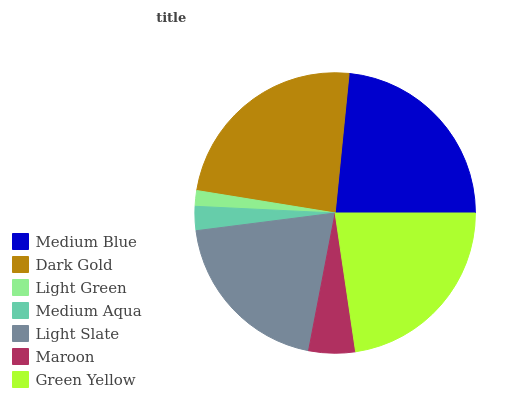Is Light Green the minimum?
Answer yes or no. Yes. Is Dark Gold the maximum?
Answer yes or no. Yes. Is Dark Gold the minimum?
Answer yes or no. No. Is Light Green the maximum?
Answer yes or no. No. Is Dark Gold greater than Light Green?
Answer yes or no. Yes. Is Light Green less than Dark Gold?
Answer yes or no. Yes. Is Light Green greater than Dark Gold?
Answer yes or no. No. Is Dark Gold less than Light Green?
Answer yes or no. No. Is Light Slate the high median?
Answer yes or no. Yes. Is Light Slate the low median?
Answer yes or no. Yes. Is Medium Aqua the high median?
Answer yes or no. No. Is Maroon the low median?
Answer yes or no. No. 